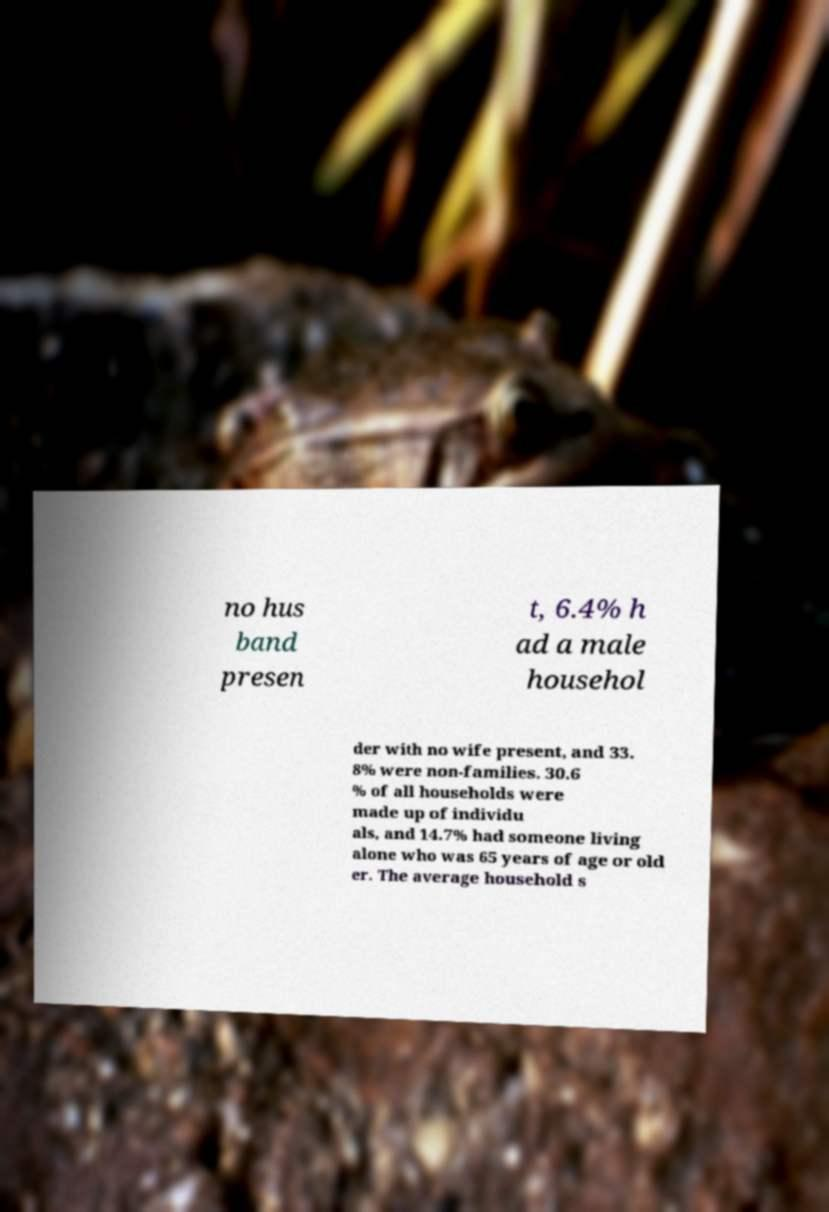Please identify and transcribe the text found in this image. no hus band presen t, 6.4% h ad a male househol der with no wife present, and 33. 8% were non-families. 30.6 % of all households were made up of individu als, and 14.7% had someone living alone who was 65 years of age or old er. The average household s 